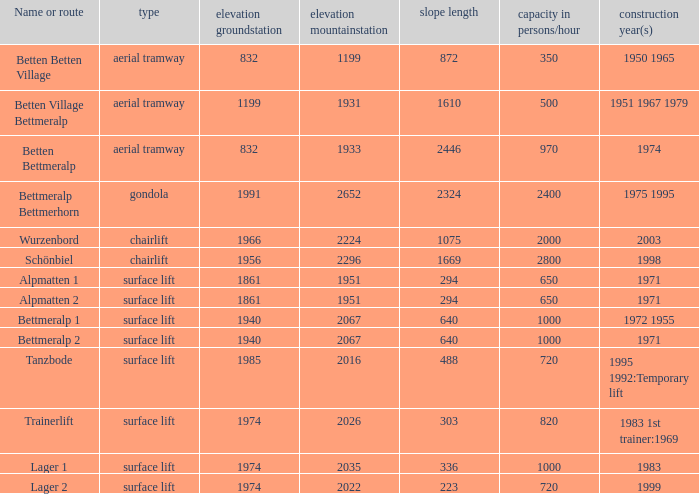At which altitude can a ground station accommodate over 820 individuals per hour, possess a name or route beyond 1, and have a slope length shorter than 336? None. 